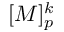Convert formula to latex. <formula><loc_0><loc_0><loc_500><loc_500>[ M ] _ { p } ^ { k }</formula> 